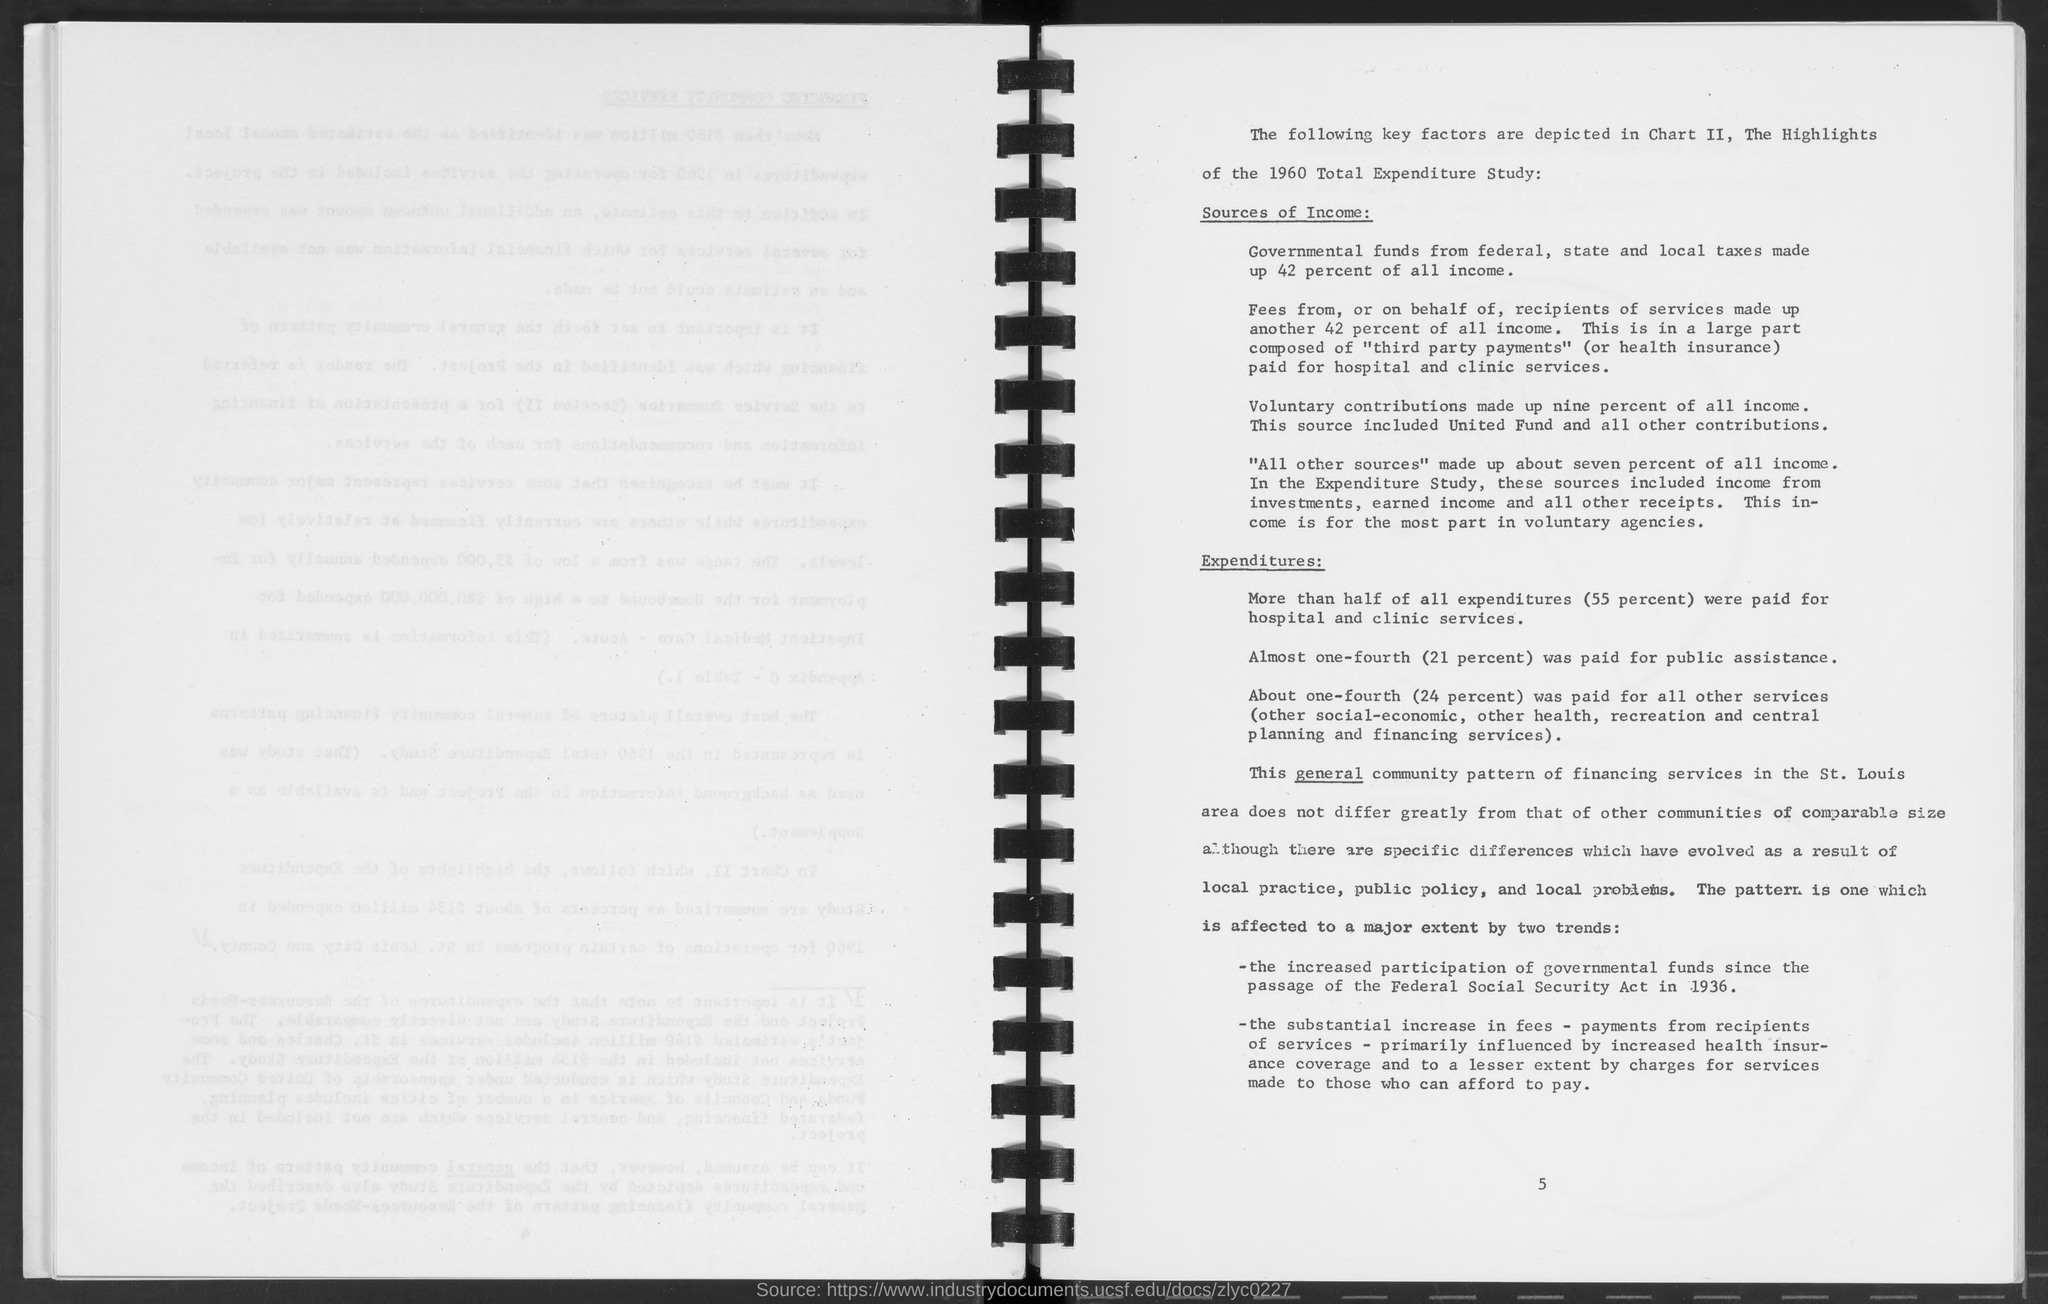Outline some significant characteristics in this image. The number at the bottom of the page is 5. 